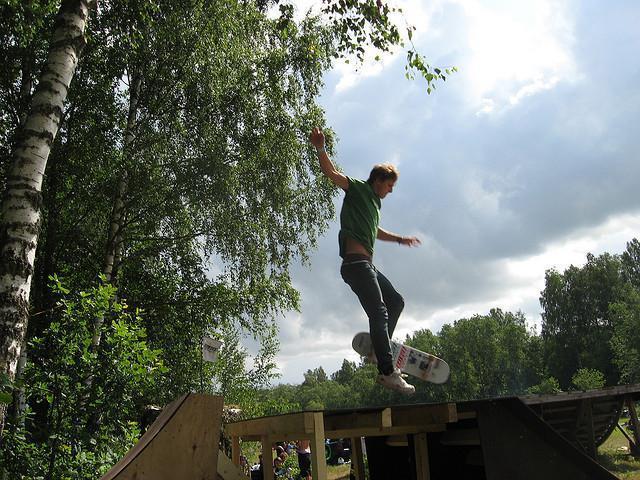How many boats are moving in the photo?
Give a very brief answer. 0. 